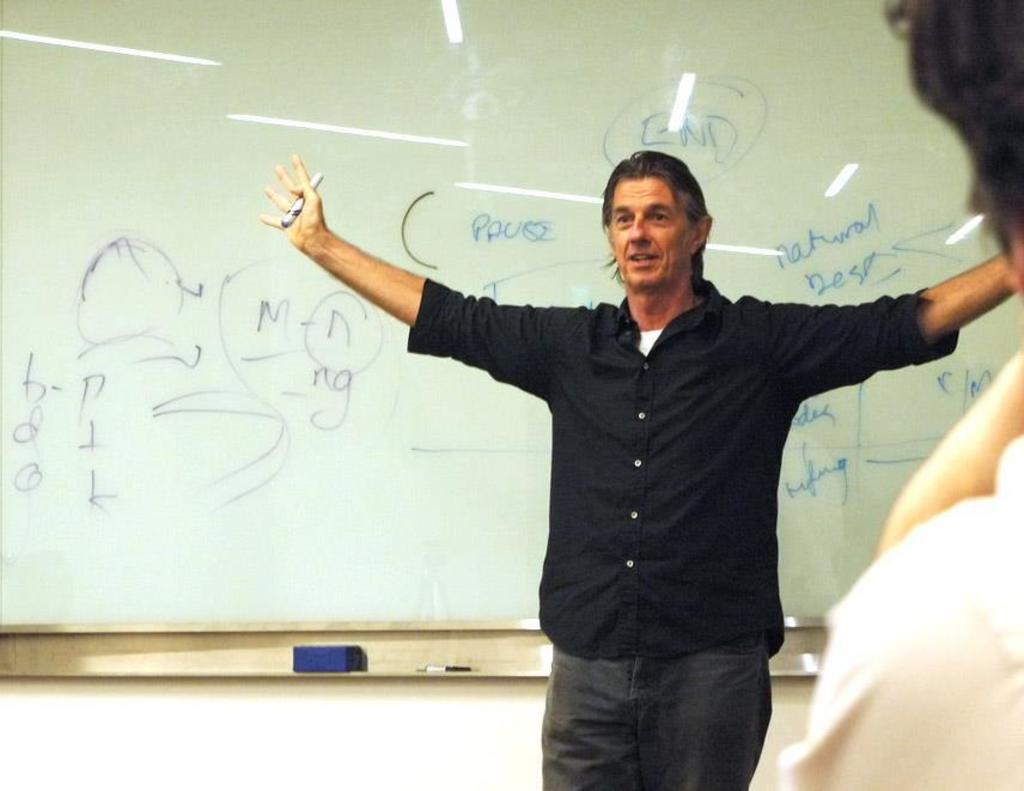<image>
Describe the image concisely. A man stands in front of a whiteboard with the word END right over his head. 